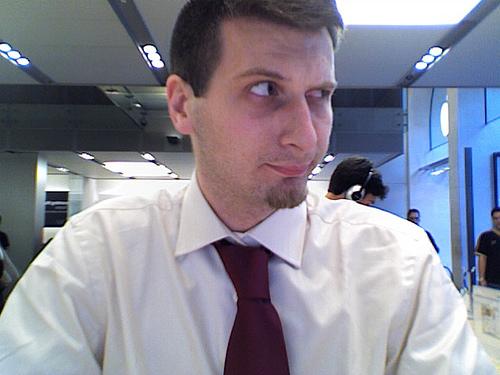What color is the man's tie?
Quick response, please. Burgundy. Is the man upset?
Quick response, please. No. Does this man have a beard?
Answer briefly. Yes. 